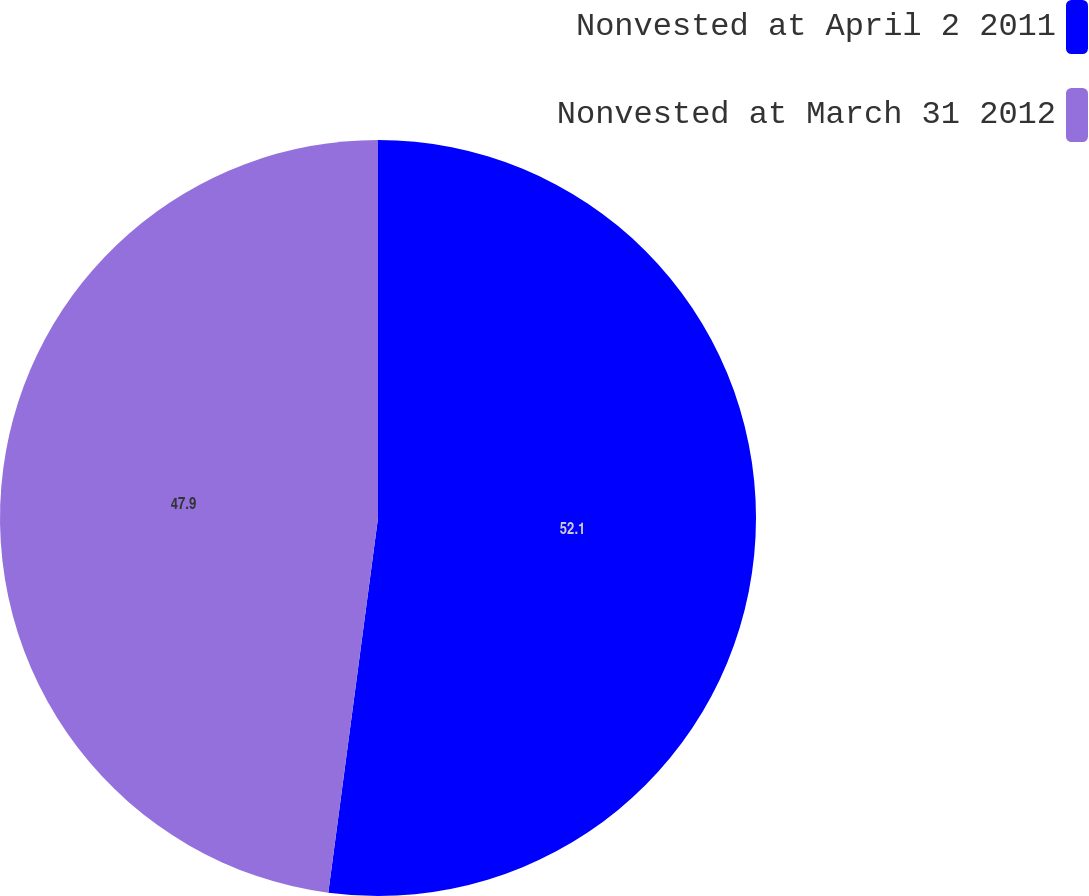Convert chart to OTSL. <chart><loc_0><loc_0><loc_500><loc_500><pie_chart><fcel>Nonvested at April 2 2011<fcel>Nonvested at March 31 2012<nl><fcel>52.1%<fcel>47.9%<nl></chart> 